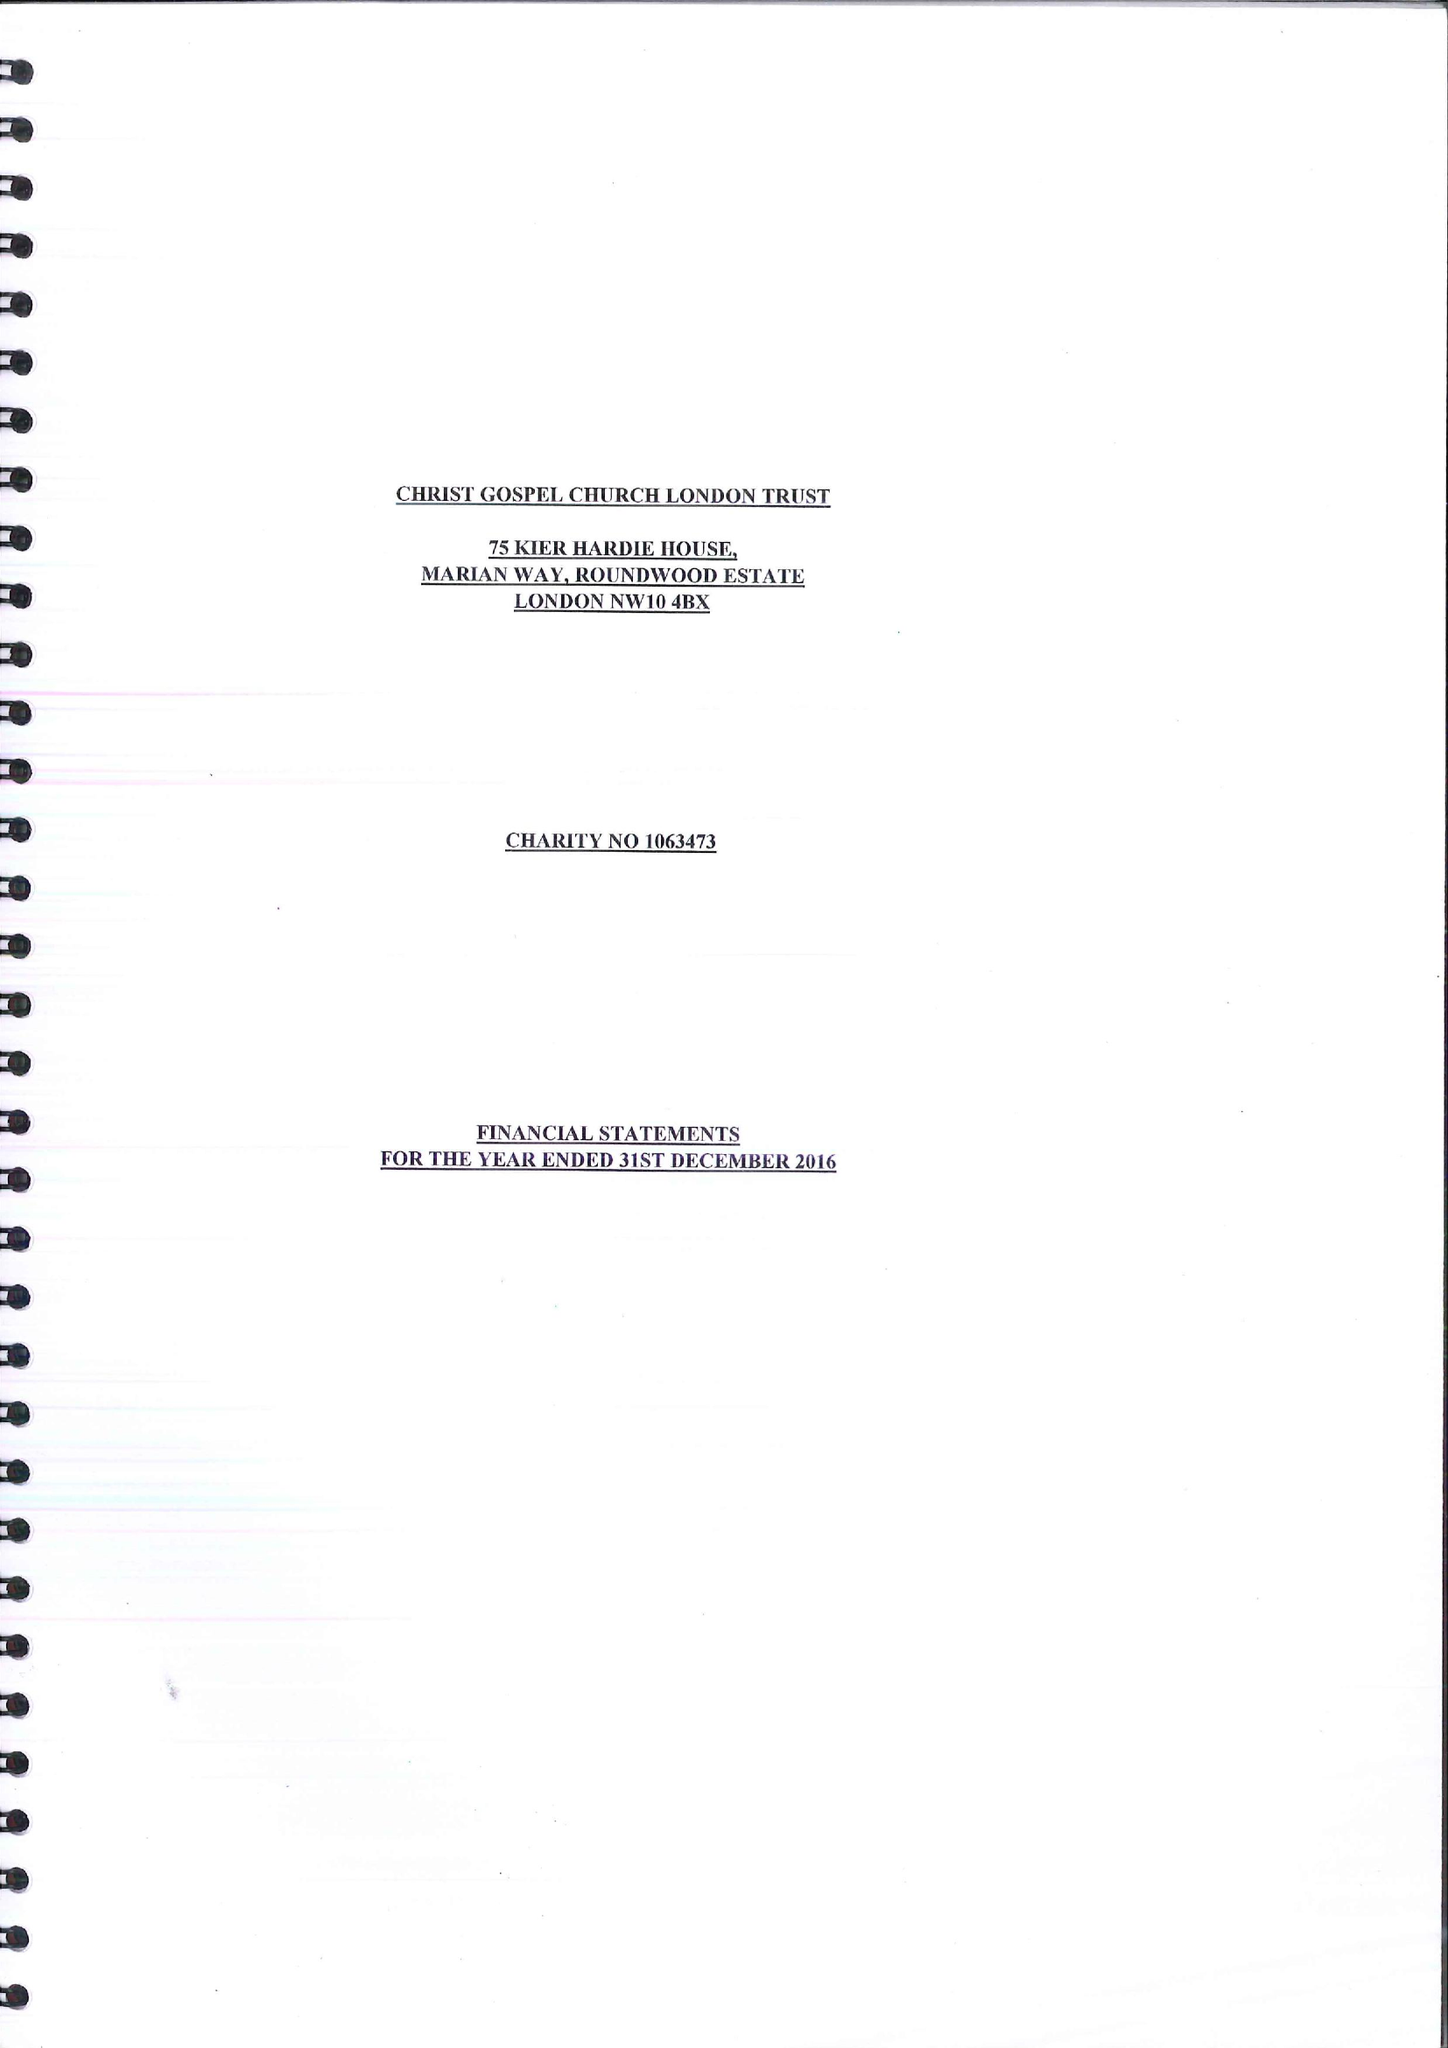What is the value for the address__postcode?
Answer the question using a single word or phrase. NW10 4BX 